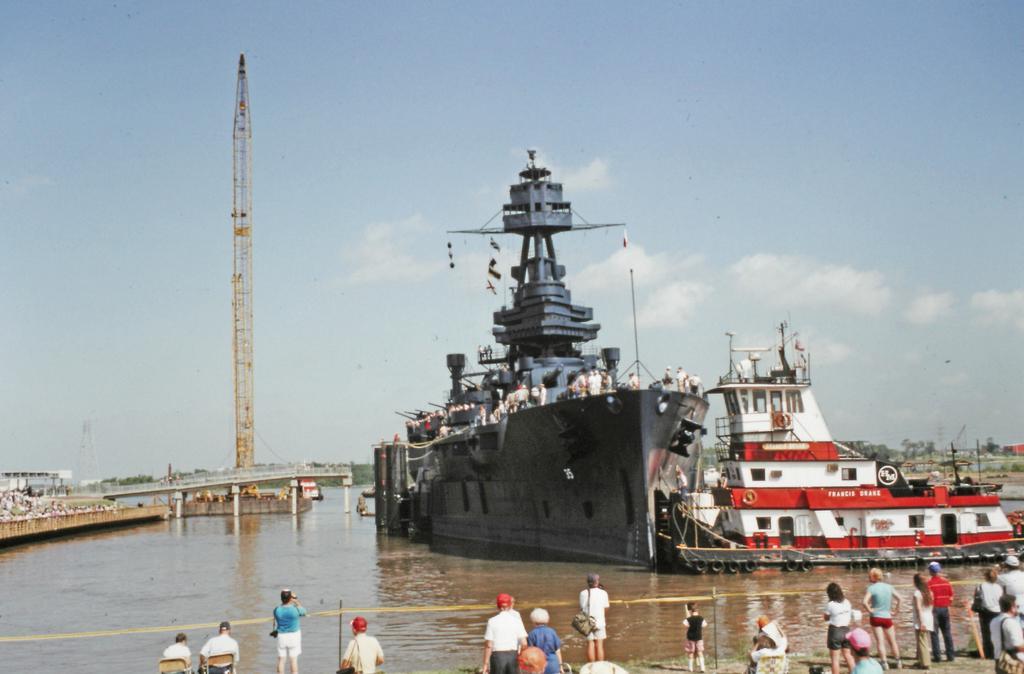Describe this image in one or two sentences. There are persons in different color dresses, some of them are standing and watching the ships which are on the water and some of them are sitting on chairs and watching. In the background, there are clouds in the sky and there is a tower on the platform. 